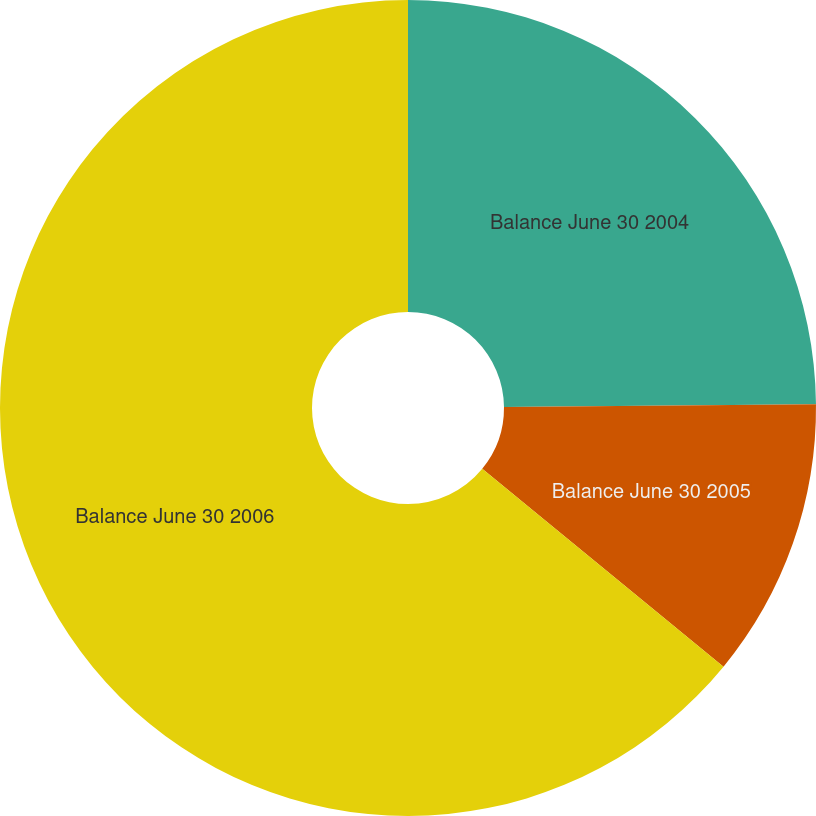Convert chart to OTSL. <chart><loc_0><loc_0><loc_500><loc_500><pie_chart><fcel>Balance June 30 2004<fcel>Balance June 30 2005<fcel>Balance June 30 2006<nl><fcel>24.85%<fcel>11.08%<fcel>64.07%<nl></chart> 